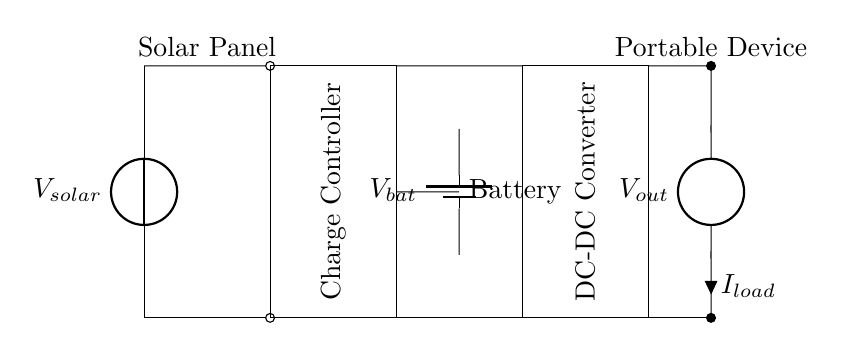What is the main function of the charge controller? The charge controller regulates the voltage and current from the solar panel to the battery, preventing overcharging.
Answer: Regulates battery charging What is the voltage source in this circuit? The voltage source is the solar panel that provides energy to the circuit. It is indicated by the label V solar.
Answer: Solar panel How many components are involved in this circuit? There are four main components in this circuit: the solar panel, charge controller, battery, and DC-DC converter.
Answer: Four What is the purpose of the DC-DC converter? The DC-DC converter adjusts the output voltage to match the requirements of the connected portable device.
Answer: Voltage adjustment What type of device can be charged using this circuit? The circuit is designed to charge portable electronic devices, as indicated by the labeled load section.
Answer: Portable devices What is the output of the battery in this circuit? The battery output voltage is denoted as V bat. Its role is to store energy from the solar panel and provide it when needed.
Answer: V bat 